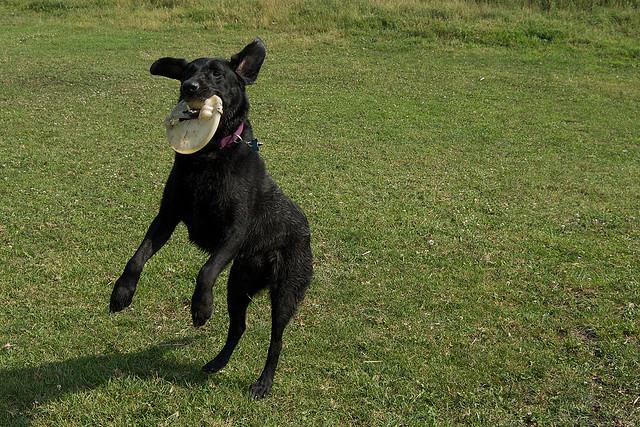How many dogs are in the photo?
Give a very brief answer. 1. What color is the dog's collar?
Quick response, please. Red. What is this dog catching?
Short answer required. Frisbee. What breed is the dog?
Keep it brief. Labrador. What breed of dog is this?
Concise answer only. Lab. What is the color of the dog?
Short answer required. Black. Are all the dogs feet touching the ground?
Short answer required. No. 